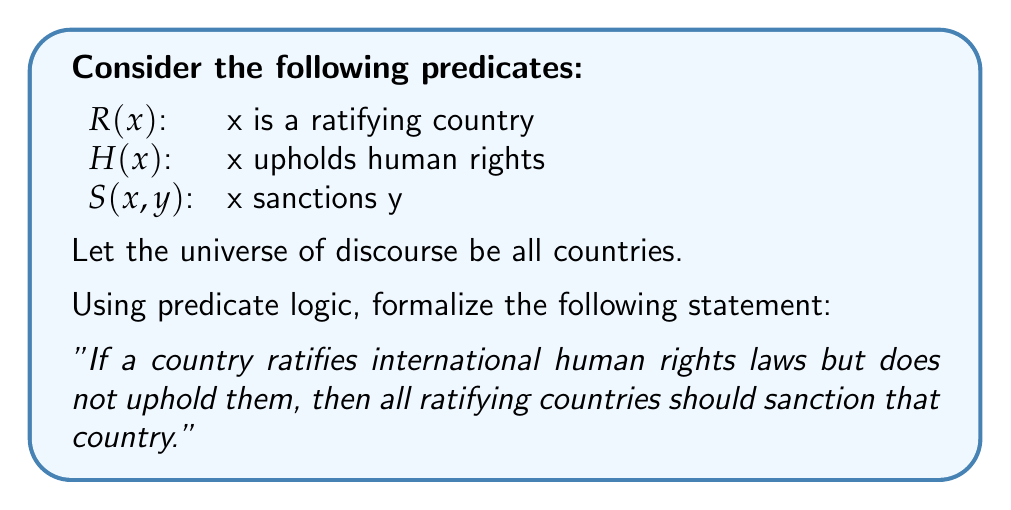Can you solve this math problem? To formalize this statement using predicate logic, we'll break it down into parts and then combine them:

1. "a country ratifies international human rights laws": $R(x)$
2. "does not uphold them (human rights)": $\neg H(x)$
3. "all ratifying countries should sanction that country": $\forall y(R(y) \rightarrow S(y,x))$

Now, let's combine these parts:

1. The condition "If a country ratifies international human rights laws but does not uphold them" can be written as:
   $R(x) \wedge \neg H(x)$

2. This condition leads to the consequence "then all ratifying countries should sanction that country":
   $\forall y(R(y) \rightarrow S(y,x))$

3. We need to express this for all countries x, so we use a universal quantifier:
   $\forall x$

4. Combining all these elements with an implication:
   $\forall x((R(x) \wedge \neg H(x)) \rightarrow \forall y(R(y) \rightarrow S(y,x)))$

This formula reads as: "For all countries x, if x ratifies international human rights laws and does not uphold human rights, then for all countries y, if y is a ratifying country, y should sanction x."
Answer: $\forall x((R(x) \wedge \neg H(x)) \rightarrow \forall y(R(y) \rightarrow S(y,x)))$ 